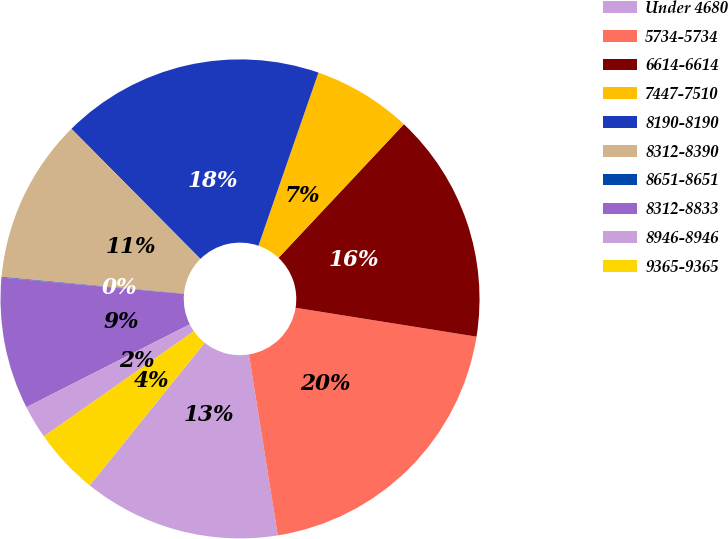<chart> <loc_0><loc_0><loc_500><loc_500><pie_chart><fcel>Under 4680<fcel>5734-5734<fcel>6614-6614<fcel>7447-7510<fcel>8190-8190<fcel>8312-8390<fcel>8651-8651<fcel>8312-8833<fcel>8946-8946<fcel>9365-9365<nl><fcel>13.32%<fcel>19.96%<fcel>15.53%<fcel>6.68%<fcel>17.74%<fcel>11.11%<fcel>0.04%<fcel>8.89%<fcel>2.26%<fcel>4.47%<nl></chart> 